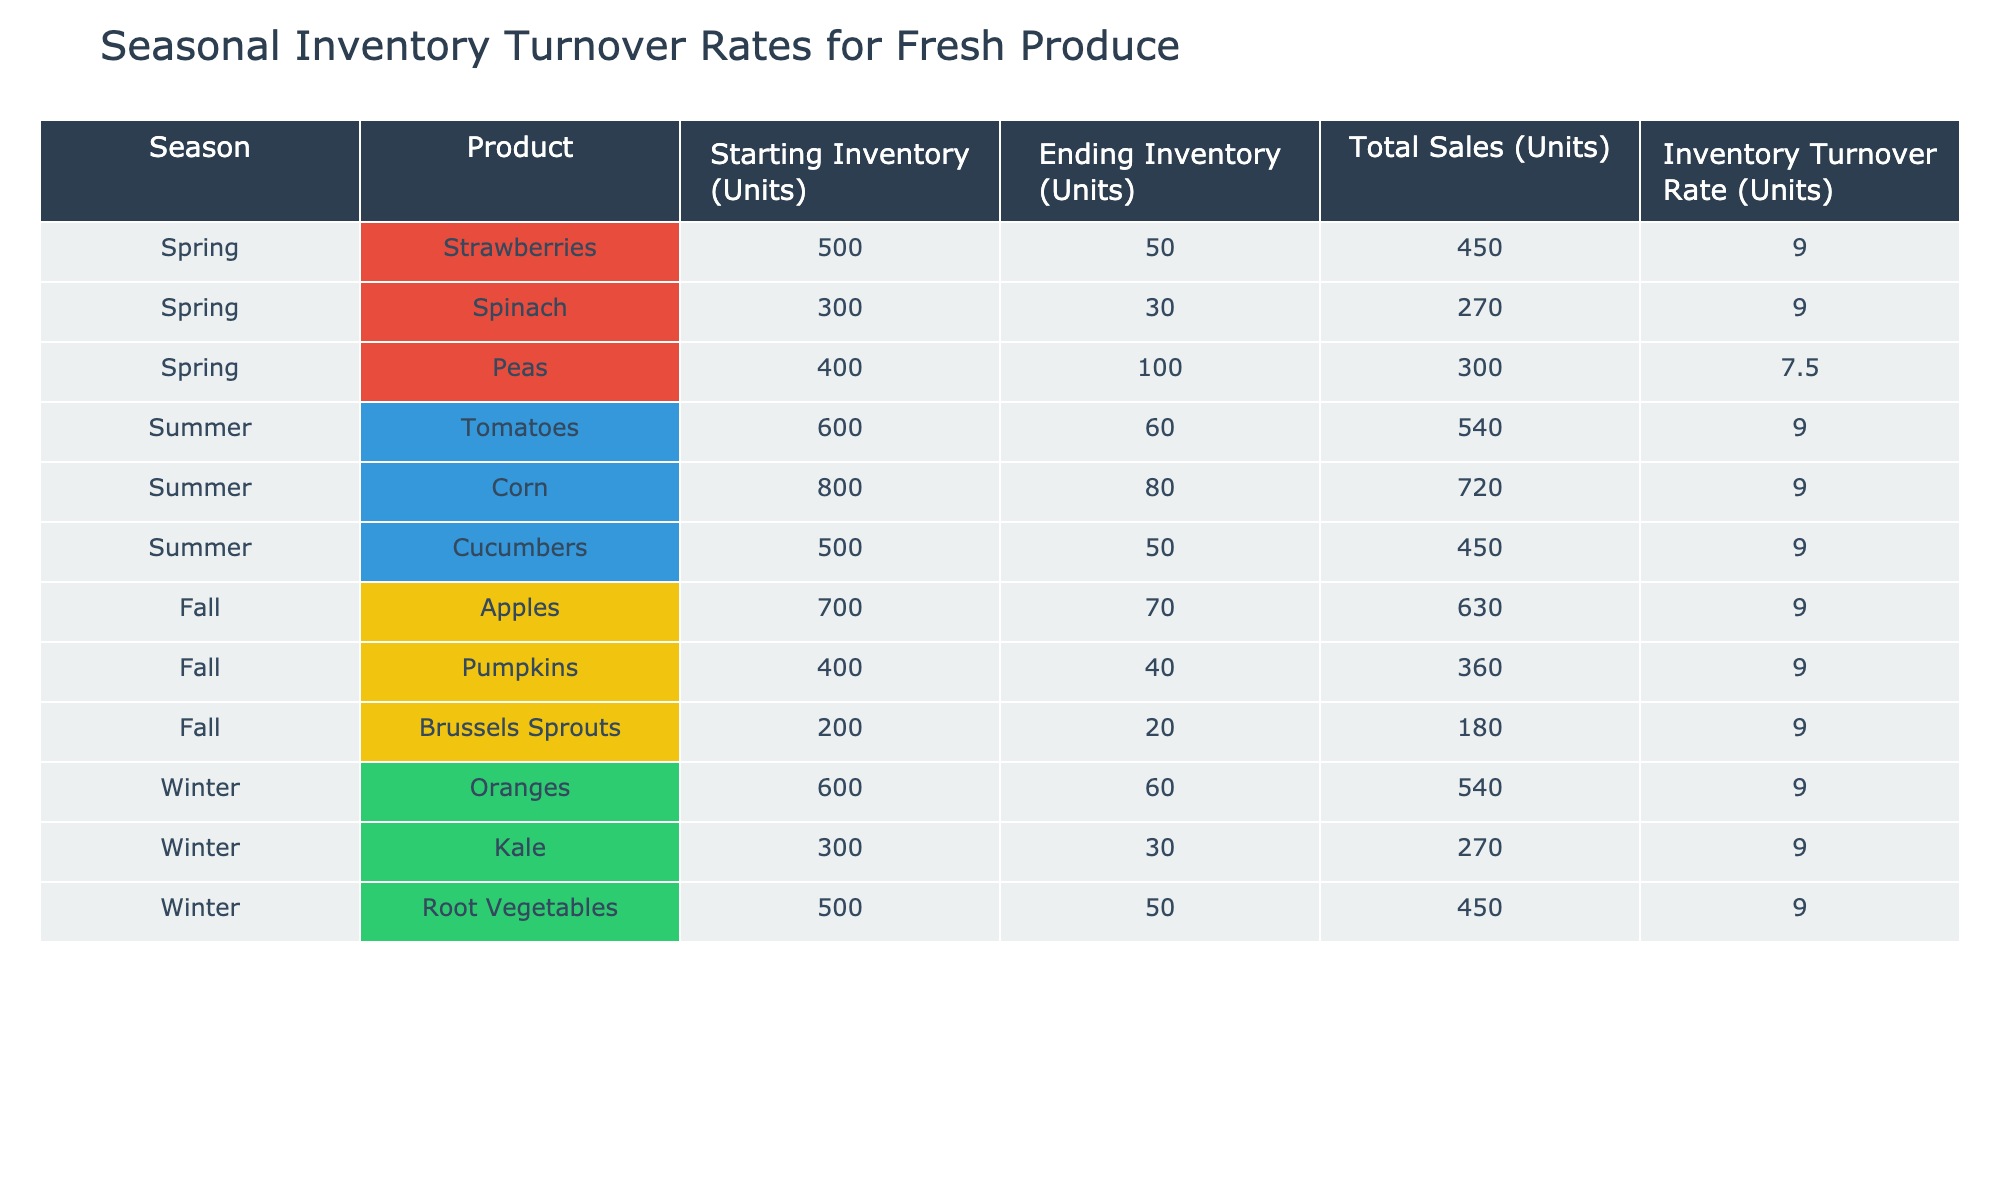What is the inventory turnover rate for tomatoes in summer? The table shows that the inventory turnover rate for tomatoes listed under the summer season is 9.0.
Answer: 9.0 Which fresh produce had the highest total sales in spring? Looking at the spring season, strawberries had the highest total sales of 450 units, compared to spinach's 270 units and peas' 300 units.
Answer: Strawberries What is the total number of units sold across all seasons? Summing the total sales from each season: 450 (Strawberries) + 270 (Spinach) + 300 (Peas) + 540 (Tomatoes) + 720 (Corn) + 450 (Cucumbers) + 630 (Apples) + 360 (Pumpkins) + 180 (Brussels Sprouts) + 540 (Oranges) + 270 (Kale) + 450 (Root Vegetables) = 4050.
Answer: 4050 units Is the ending inventory for oranges higher than that for root vegetables? The ending inventory for oranges is 60 units and for root vegetables is also 50 units. Since 60 > 50, the statement is true.
Answer: Yes What is the average inventory turnover rate for all seasons combined? There are 12 data points with an inventory turnover rate of 9.0 for each product. Therefore, the average can be calculated as (9.0 * 12) / 12 = 9.0.
Answer: 9.0 Which season had the lowest total sales, and what was the value? Reviewing the total sales by season: Spring: 450 + 270 + 300 = 1020, Summer: 540 + 720 + 450 = 1710, Fall: 630 + 360 + 180 = 1170, Winter: 540 + 270 + 450 = 1260. The lowest total sales were in spring with 1020.
Answer: Spring, 1020 units How many more units of spinach were sold compared to Brussels sprouts? Spinach had 270 units sold, while Brussels sprouts had 180 units sold. The difference is 270 - 180 = 90 units.
Answer: 90 units Is the total sales for summer produce greater than the total sales for winter produce? The total sales for summer produce are 1710 units (540 tomatoes + 720 corn + 450 cucumbers) while for winter it is 1260 units (540 oranges + 270 kale + 450 root vegetables). Here, 1710 > 1260, thus, summer's total sales are greater than winter's.
Answer: Yes 